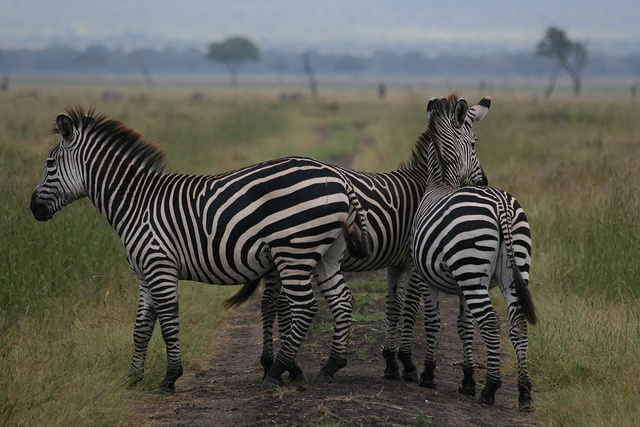Describe the objects in this image and their specific colors. I can see zebra in darkgray, black, gray, and darkgreen tones, zebra in darkgray, black, gray, and darkgreen tones, and zebra in darkgray, black, and gray tones in this image. 